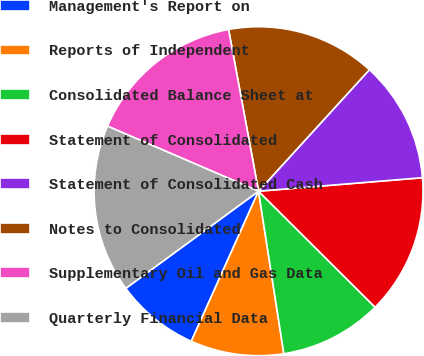Convert chart. <chart><loc_0><loc_0><loc_500><loc_500><pie_chart><fcel>Management's Report on<fcel>Reports of Independent<fcel>Consolidated Balance Sheet at<fcel>Statement of Consolidated<fcel>Statement of Consolidated Cash<fcel>Notes to Consolidated<fcel>Supplementary Oil and Gas Data<fcel>Quarterly Financial Data<nl><fcel>8.24%<fcel>9.16%<fcel>10.08%<fcel>13.77%<fcel>11.92%<fcel>14.69%<fcel>15.61%<fcel>16.53%<nl></chart> 